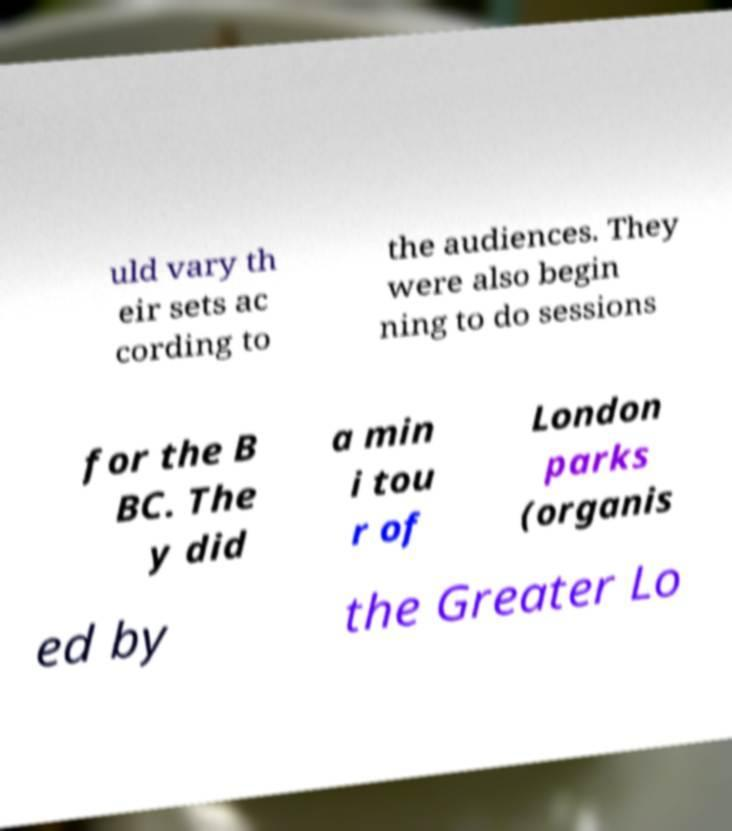Could you assist in decoding the text presented in this image and type it out clearly? uld vary th eir sets ac cording to the audiences. They were also begin ning to do sessions for the B BC. The y did a min i tou r of London parks (organis ed by the Greater Lo 